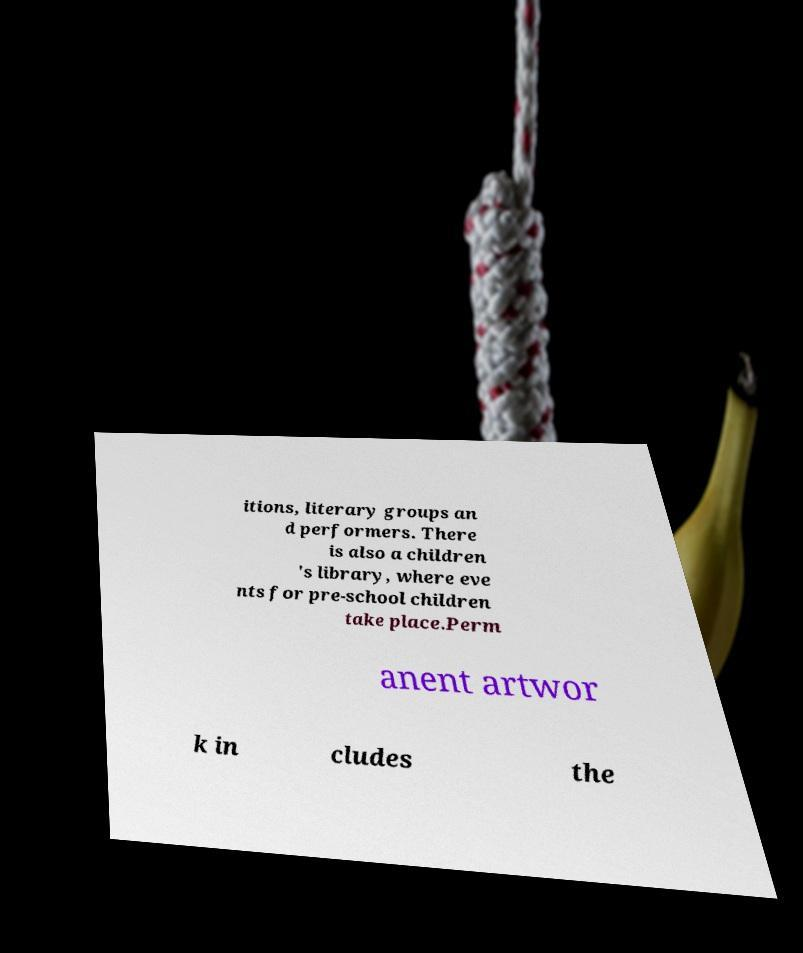What messages or text are displayed in this image? I need them in a readable, typed format. itions, literary groups an d performers. There is also a children 's library, where eve nts for pre-school children take place.Perm anent artwor k in cludes the 